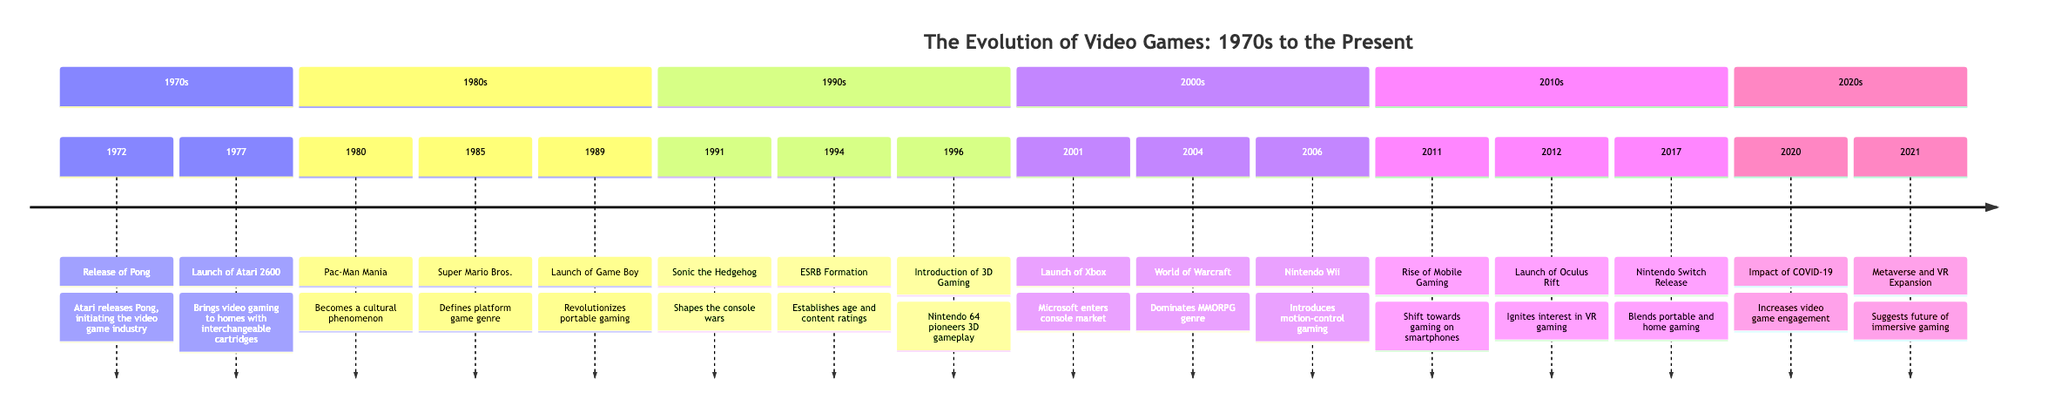What game did Atari release in 1972? This question refers to the event in the 1970s section of the timeline where it lists the game Pong. Looking at the diagram, the significant event in 1972 is clearly marked as the release of Pong.
Answer: Pong What year was the Atari 2600 launched? The timeline shows that the Atari 2600 was launched in 1977, making it easy to locate the specific year just by looking at the respective event in the 1970s section.
Answer: 1977 Which decade saw the release of Super Mario Bros.? The timeline details that Super Mario Bros. was released in 1985, which falls under the 1980s. By checking the events listed, we can see that Super Mario Bros. is indeed highlighted in that decade.
Answer: 1980s How many cultural phenomena are noted in the 1980s? This requires counting the events in the 1980s section. The timeline mentions three significant events, which include Pac-Man, Super Mario Bros., and Game Boy, all of which had a strong cultural impact.
Answer: 3 Which game introduced 3D gameplay in 1996? The diagram indicates that the introduction of 3D gaming correlates with the Nintendo 64, launching alongside Super Mario 64 in 1996, specifically pointing out the game's significance in pioneering 3D gameplay.
Answer: Super Mario 64 What was the impact of the COVID-19 pandemic on gaming in 2020? The timeline states that the COVID-19 pandemic led to a significant increase in video game engagement as people sought entertainment and social interaction during lockdowns. Analyzing the 2020s section, it's clear that the gaming landscape was notably influenced in that year.
Answer: Increase in engagement What notable console did Microsoft launch in 2001? The event in 2001 is specifically about the launch of the Xbox by Microsoft, which is directly indicated in the timeline. There is no ambiguity as it is explicitly stated.
Answer: Xbox Which major MMORPG was released in 2004? Referring to the diagram, World of Warcraft is listed as the significant event in 2004, which is a widely recognized MMORPG. Checking the section identifies the title specifically.
Answer: World of Warcraft How did the Nintendo Wii revolutionize gaming in 2006? This involves understanding the innovative contribution of the Nintendo Wii as described in the timeline, particularly that it introduced motion-control gaming, thus transforming the gaming experience for many players.
Answer: Motion-control gaming In which year did Oculus Rift launch? By looking at the 2010s section of the timeline, it is stated that Oculus Rift was launched in 2012, allowing us to pinpoint the specific year easily.
Answer: 2012 